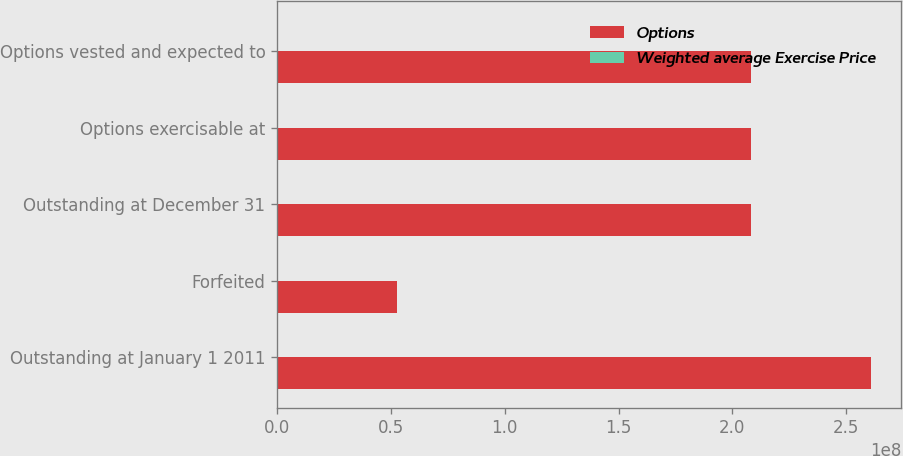<chart> <loc_0><loc_0><loc_500><loc_500><stacked_bar_chart><ecel><fcel>Outstanding at January 1 2011<fcel>Forfeited<fcel>Outstanding at December 31<fcel>Options exercisable at<fcel>Options vested and expected to<nl><fcel>Options<fcel>2.61123e+08<fcel>5.28533e+07<fcel>2.0827e+08<fcel>2.08259e+08<fcel>2.0827e+08<nl><fcel>Weighted average Exercise Price<fcel>50.61<fcel>65.12<fcel>46.93<fcel>46.93<fcel>46.93<nl></chart> 